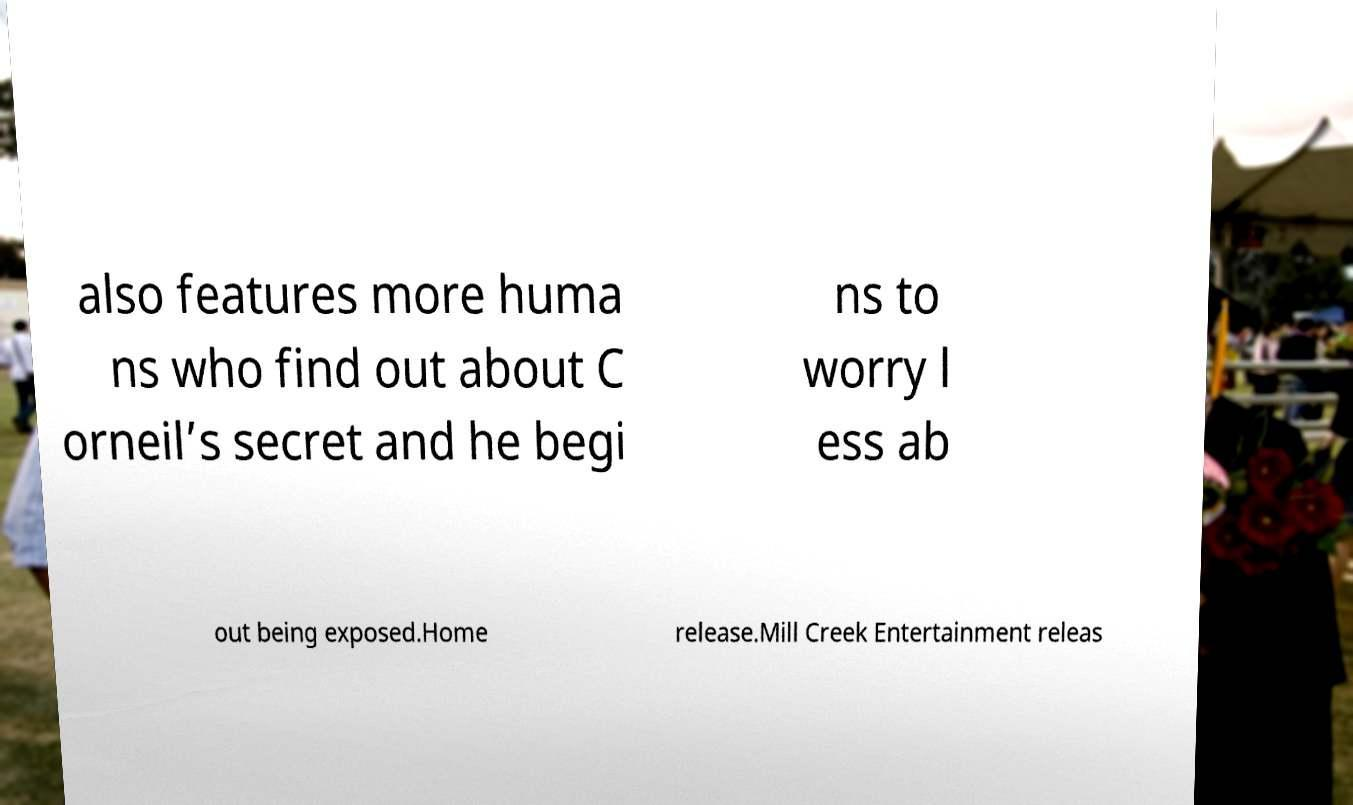Could you extract and type out the text from this image? also features more huma ns who find out about C orneil’s secret and he begi ns to worry l ess ab out being exposed.Home release.Mill Creek Entertainment releas 